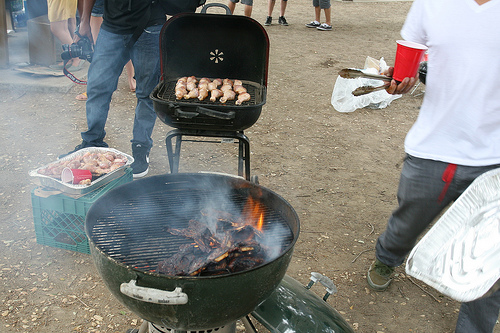<image>
Is there a cup on the tongs? Yes. Looking at the image, I can see the cup is positioned on top of the tongs, with the tongs providing support. Is there a food to the left of the grill? Yes. From this viewpoint, the food is positioned to the left side relative to the grill. Where is the man in relation to the grill? Is it behind the grill? No. The man is not behind the grill. From this viewpoint, the man appears to be positioned elsewhere in the scene. 